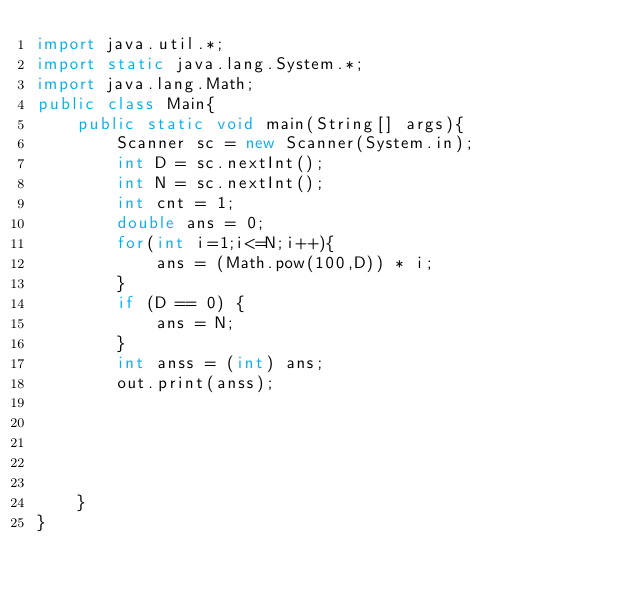Convert code to text. <code><loc_0><loc_0><loc_500><loc_500><_Java_>import java.util.*;
import static java.lang.System.*;
import java.lang.Math;
public class Main{
    public static void main(String[] args){
        Scanner sc = new Scanner(System.in);
        int D = sc.nextInt();
        int N = sc.nextInt();
        int cnt = 1;
        double ans = 0;
        for(int i=1;i<=N;i++){
            ans = (Math.pow(100,D)) * i;
        }
        if (D == 0) {
            ans = N;
        }
        int anss = (int) ans;
        out.print(anss);
        
        
        
        
       
    }
}
</code> 